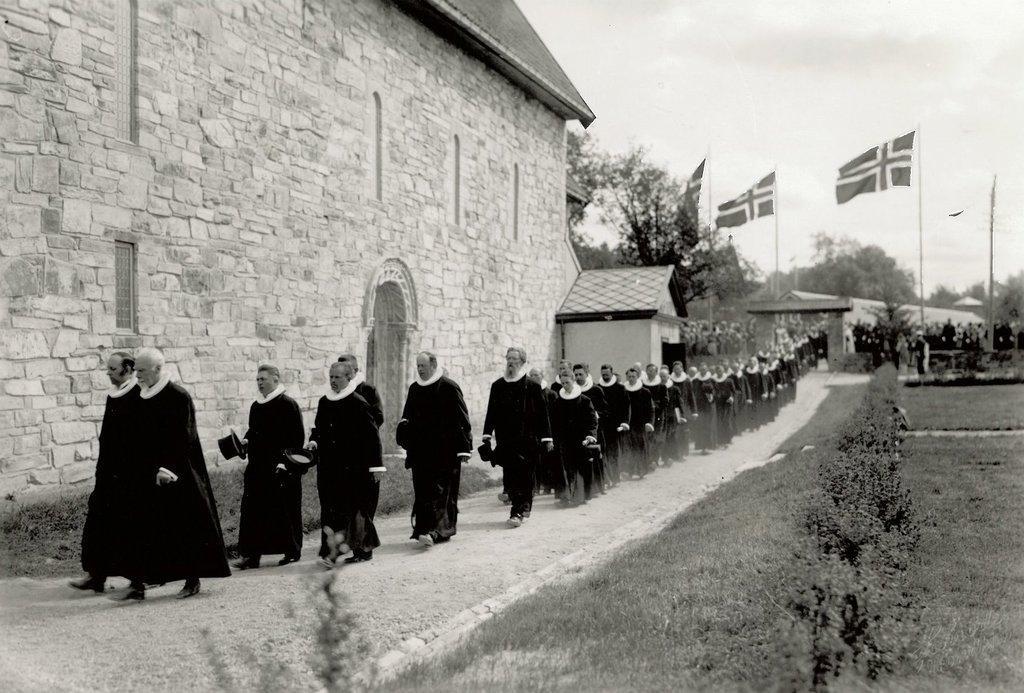Could you give a brief overview of what you see in this image? In the given image i can see a houses,flags,trees,people,plants and grass. 